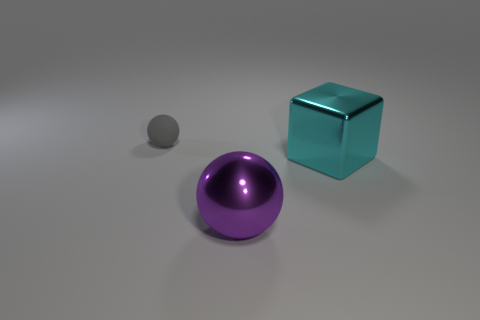Add 2 blocks. How many objects exist? 5 Subtract all blocks. How many objects are left? 2 Subtract 0 yellow balls. How many objects are left? 3 Subtract all tiny brown rubber cubes. Subtract all cyan cubes. How many objects are left? 2 Add 3 big purple metal objects. How many big purple metal objects are left? 4 Add 3 red shiny cubes. How many red shiny cubes exist? 3 